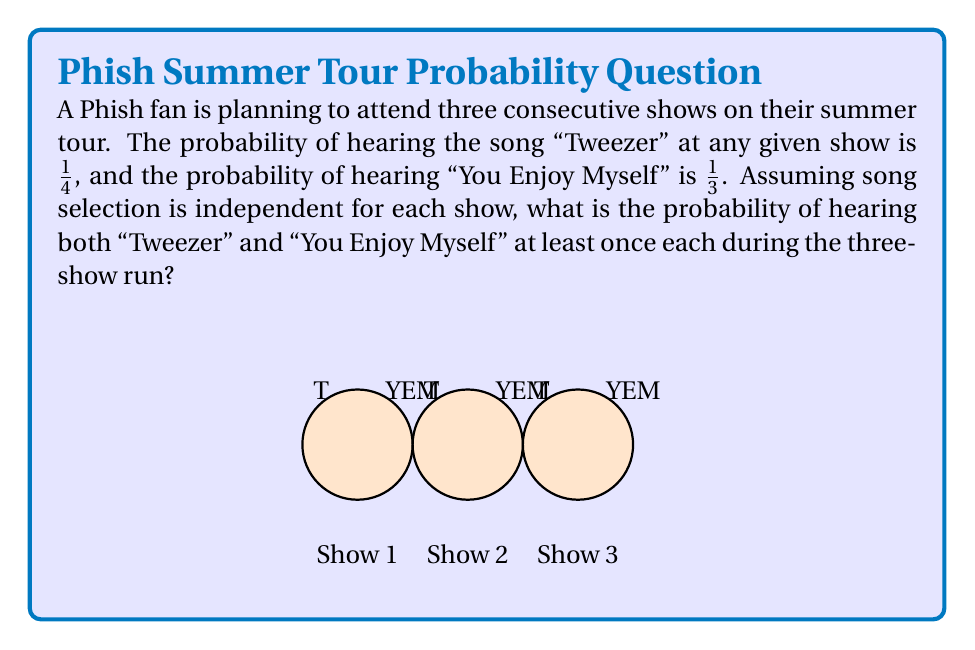Solve this math problem. Let's approach this step-by-step:

1) First, let's calculate the probability of NOT hearing each song at a single show:
   P(No Tweezer) = $1 - \frac{1}{4} = \frac{3}{4}$
   P(No YEM) = $1 - \frac{1}{3} = \frac{2}{3}$

2) Now, the probability of not hearing Tweezer in all three shows:
   $P(\text{No Tweezer in 3 shows}) = (\frac{3}{4})^3 = \frac{27}{64}$

3) Similarly, for YEM:
   $P(\text{No YEM in 3 shows}) = (\frac{2}{3})^3 = \frac{8}{27}$

4) The probability of hearing both songs at least once is the opposite of not hearing at least one of them. So we need to calculate:
   $1 - P(\text{No Tweezer OR No YEM in 3 shows})$

5) Using the addition rule of probability:
   $P(\text{No Tweezer OR No YEM}) = P(\text{No Tweezer}) + P(\text{No YEM}) - P(\text{No Tweezer AND No YEM})$

6) $P(\text{No Tweezer AND No YEM}) = \frac{27}{64} \cdot \frac{8}{27} = \frac{6}{64}$

7) Therefore:
   $P(\text{No Tweezer OR No YEM}) = \frac{27}{64} + \frac{8}{27} - \frac{6}{64} = \frac{27}{64} + \frac{512}{1728} - \frac{6}{64} = \frac{21}{64} + \frac{512}{1728}$

8) Finally, the probability of hearing both songs at least once:
   $1 - (\frac{21}{64} + \frac{512}{1728}) = 1 - \frac{1183}{1728} = \frac{545}{1728} \approx 0.3154$
Answer: $\frac{545}{1728}$ 